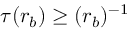<formula> <loc_0><loc_0><loc_500><loc_500>\tau ( r _ { b } ) \geq ( r _ { b } ) ^ { - 1 }</formula> 